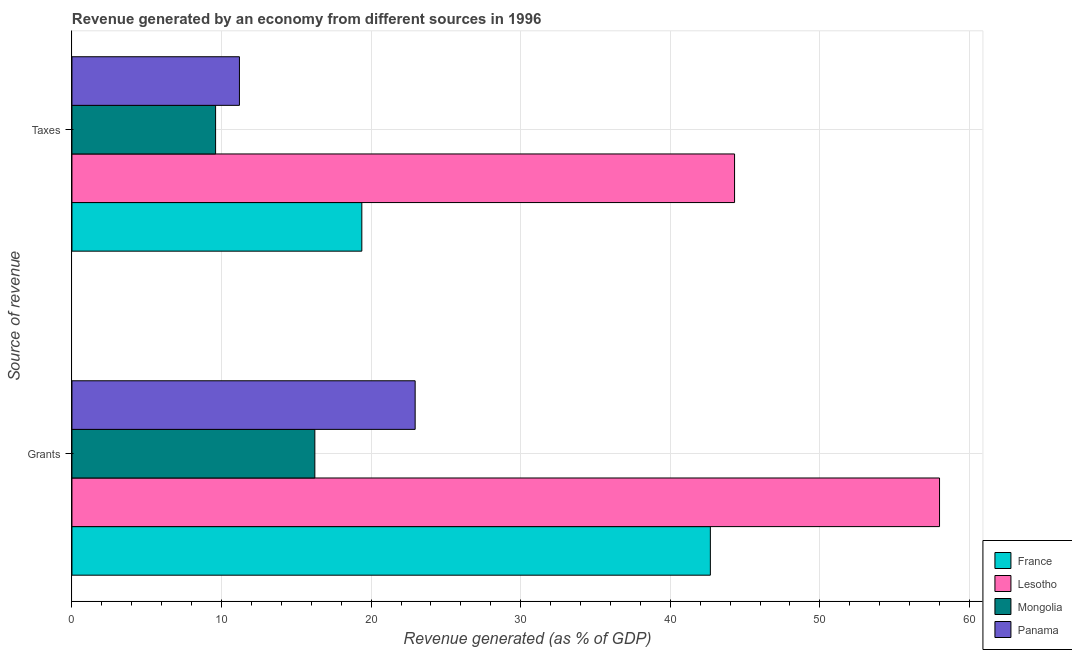How many different coloured bars are there?
Make the answer very short. 4. How many groups of bars are there?
Your answer should be very brief. 2. How many bars are there on the 1st tick from the top?
Offer a very short reply. 4. How many bars are there on the 1st tick from the bottom?
Provide a short and direct response. 4. What is the label of the 2nd group of bars from the top?
Ensure brevity in your answer.  Grants. What is the revenue generated by taxes in Panama?
Your answer should be very brief. 11.2. Across all countries, what is the maximum revenue generated by grants?
Offer a terse response. 58. Across all countries, what is the minimum revenue generated by taxes?
Your answer should be very brief. 9.6. In which country was the revenue generated by taxes maximum?
Give a very brief answer. Lesotho. In which country was the revenue generated by taxes minimum?
Your answer should be very brief. Mongolia. What is the total revenue generated by grants in the graph?
Offer a terse response. 139.86. What is the difference between the revenue generated by grants in Mongolia and that in France?
Your answer should be very brief. -26.44. What is the difference between the revenue generated by grants in Lesotho and the revenue generated by taxes in France?
Make the answer very short. 38.62. What is the average revenue generated by taxes per country?
Ensure brevity in your answer.  21.12. What is the difference between the revenue generated by taxes and revenue generated by grants in Panama?
Offer a terse response. -11.75. What is the ratio of the revenue generated by taxes in France to that in Panama?
Keep it short and to the point. 1.73. In how many countries, is the revenue generated by taxes greater than the average revenue generated by taxes taken over all countries?
Make the answer very short. 1. What does the 1st bar from the top in Grants represents?
Provide a succinct answer. Panama. Are all the bars in the graph horizontal?
Your answer should be very brief. Yes. How many countries are there in the graph?
Offer a terse response. 4. What is the difference between two consecutive major ticks on the X-axis?
Ensure brevity in your answer.  10. Are the values on the major ticks of X-axis written in scientific E-notation?
Give a very brief answer. No. Does the graph contain any zero values?
Keep it short and to the point. No. Where does the legend appear in the graph?
Provide a short and direct response. Bottom right. How many legend labels are there?
Give a very brief answer. 4. What is the title of the graph?
Give a very brief answer. Revenue generated by an economy from different sources in 1996. What is the label or title of the X-axis?
Your answer should be very brief. Revenue generated (as % of GDP). What is the label or title of the Y-axis?
Keep it short and to the point. Source of revenue. What is the Revenue generated (as % of GDP) in France in Grants?
Your response must be concise. 42.68. What is the Revenue generated (as % of GDP) of Lesotho in Grants?
Keep it short and to the point. 58. What is the Revenue generated (as % of GDP) of Mongolia in Grants?
Offer a terse response. 16.24. What is the Revenue generated (as % of GDP) in Panama in Grants?
Provide a short and direct response. 22.94. What is the Revenue generated (as % of GDP) of France in Taxes?
Provide a short and direct response. 19.38. What is the Revenue generated (as % of GDP) in Lesotho in Taxes?
Give a very brief answer. 44.3. What is the Revenue generated (as % of GDP) in Mongolia in Taxes?
Offer a very short reply. 9.6. What is the Revenue generated (as % of GDP) in Panama in Taxes?
Your answer should be very brief. 11.2. Across all Source of revenue, what is the maximum Revenue generated (as % of GDP) of France?
Your answer should be very brief. 42.68. Across all Source of revenue, what is the maximum Revenue generated (as % of GDP) in Lesotho?
Your answer should be very brief. 58. Across all Source of revenue, what is the maximum Revenue generated (as % of GDP) in Mongolia?
Give a very brief answer. 16.24. Across all Source of revenue, what is the maximum Revenue generated (as % of GDP) of Panama?
Give a very brief answer. 22.94. Across all Source of revenue, what is the minimum Revenue generated (as % of GDP) in France?
Ensure brevity in your answer.  19.38. Across all Source of revenue, what is the minimum Revenue generated (as % of GDP) of Lesotho?
Make the answer very short. 44.3. Across all Source of revenue, what is the minimum Revenue generated (as % of GDP) in Mongolia?
Your answer should be very brief. 9.6. Across all Source of revenue, what is the minimum Revenue generated (as % of GDP) in Panama?
Offer a very short reply. 11.2. What is the total Revenue generated (as % of GDP) in France in the graph?
Your response must be concise. 62.06. What is the total Revenue generated (as % of GDP) in Lesotho in the graph?
Your answer should be very brief. 102.29. What is the total Revenue generated (as % of GDP) of Mongolia in the graph?
Offer a terse response. 25.84. What is the total Revenue generated (as % of GDP) in Panama in the graph?
Provide a short and direct response. 34.14. What is the difference between the Revenue generated (as % of GDP) in France in Grants and that in Taxes?
Provide a succinct answer. 23.3. What is the difference between the Revenue generated (as % of GDP) in Lesotho in Grants and that in Taxes?
Give a very brief answer. 13.7. What is the difference between the Revenue generated (as % of GDP) of Mongolia in Grants and that in Taxes?
Provide a short and direct response. 6.63. What is the difference between the Revenue generated (as % of GDP) of Panama in Grants and that in Taxes?
Ensure brevity in your answer.  11.75. What is the difference between the Revenue generated (as % of GDP) of France in Grants and the Revenue generated (as % of GDP) of Lesotho in Taxes?
Offer a terse response. -1.62. What is the difference between the Revenue generated (as % of GDP) in France in Grants and the Revenue generated (as % of GDP) in Mongolia in Taxes?
Your answer should be compact. 33.08. What is the difference between the Revenue generated (as % of GDP) in France in Grants and the Revenue generated (as % of GDP) in Panama in Taxes?
Offer a very short reply. 31.48. What is the difference between the Revenue generated (as % of GDP) of Lesotho in Grants and the Revenue generated (as % of GDP) of Mongolia in Taxes?
Offer a terse response. 48.4. What is the difference between the Revenue generated (as % of GDP) of Lesotho in Grants and the Revenue generated (as % of GDP) of Panama in Taxes?
Offer a very short reply. 46.8. What is the difference between the Revenue generated (as % of GDP) in Mongolia in Grants and the Revenue generated (as % of GDP) in Panama in Taxes?
Your answer should be very brief. 5.04. What is the average Revenue generated (as % of GDP) in France per Source of revenue?
Keep it short and to the point. 31.03. What is the average Revenue generated (as % of GDP) in Lesotho per Source of revenue?
Ensure brevity in your answer.  51.15. What is the average Revenue generated (as % of GDP) in Mongolia per Source of revenue?
Your answer should be very brief. 12.92. What is the average Revenue generated (as % of GDP) of Panama per Source of revenue?
Your answer should be very brief. 17.07. What is the difference between the Revenue generated (as % of GDP) of France and Revenue generated (as % of GDP) of Lesotho in Grants?
Give a very brief answer. -15.32. What is the difference between the Revenue generated (as % of GDP) of France and Revenue generated (as % of GDP) of Mongolia in Grants?
Provide a succinct answer. 26.44. What is the difference between the Revenue generated (as % of GDP) in France and Revenue generated (as % of GDP) in Panama in Grants?
Ensure brevity in your answer.  19.74. What is the difference between the Revenue generated (as % of GDP) of Lesotho and Revenue generated (as % of GDP) of Mongolia in Grants?
Your response must be concise. 41.76. What is the difference between the Revenue generated (as % of GDP) in Lesotho and Revenue generated (as % of GDP) in Panama in Grants?
Provide a succinct answer. 35.06. What is the difference between the Revenue generated (as % of GDP) in Mongolia and Revenue generated (as % of GDP) in Panama in Grants?
Keep it short and to the point. -6.71. What is the difference between the Revenue generated (as % of GDP) in France and Revenue generated (as % of GDP) in Lesotho in Taxes?
Your answer should be very brief. -24.92. What is the difference between the Revenue generated (as % of GDP) of France and Revenue generated (as % of GDP) of Mongolia in Taxes?
Give a very brief answer. 9.78. What is the difference between the Revenue generated (as % of GDP) of France and Revenue generated (as % of GDP) of Panama in Taxes?
Provide a succinct answer. 8.18. What is the difference between the Revenue generated (as % of GDP) of Lesotho and Revenue generated (as % of GDP) of Mongolia in Taxes?
Your answer should be very brief. 34.69. What is the difference between the Revenue generated (as % of GDP) in Lesotho and Revenue generated (as % of GDP) in Panama in Taxes?
Provide a short and direct response. 33.1. What is the difference between the Revenue generated (as % of GDP) in Mongolia and Revenue generated (as % of GDP) in Panama in Taxes?
Provide a short and direct response. -1.59. What is the ratio of the Revenue generated (as % of GDP) in France in Grants to that in Taxes?
Your answer should be very brief. 2.2. What is the ratio of the Revenue generated (as % of GDP) in Lesotho in Grants to that in Taxes?
Ensure brevity in your answer.  1.31. What is the ratio of the Revenue generated (as % of GDP) of Mongolia in Grants to that in Taxes?
Keep it short and to the point. 1.69. What is the ratio of the Revenue generated (as % of GDP) of Panama in Grants to that in Taxes?
Offer a very short reply. 2.05. What is the difference between the highest and the second highest Revenue generated (as % of GDP) in France?
Give a very brief answer. 23.3. What is the difference between the highest and the second highest Revenue generated (as % of GDP) of Lesotho?
Offer a very short reply. 13.7. What is the difference between the highest and the second highest Revenue generated (as % of GDP) in Mongolia?
Keep it short and to the point. 6.63. What is the difference between the highest and the second highest Revenue generated (as % of GDP) of Panama?
Your answer should be compact. 11.75. What is the difference between the highest and the lowest Revenue generated (as % of GDP) of France?
Offer a very short reply. 23.3. What is the difference between the highest and the lowest Revenue generated (as % of GDP) in Lesotho?
Your answer should be very brief. 13.7. What is the difference between the highest and the lowest Revenue generated (as % of GDP) of Mongolia?
Give a very brief answer. 6.63. What is the difference between the highest and the lowest Revenue generated (as % of GDP) in Panama?
Provide a short and direct response. 11.75. 